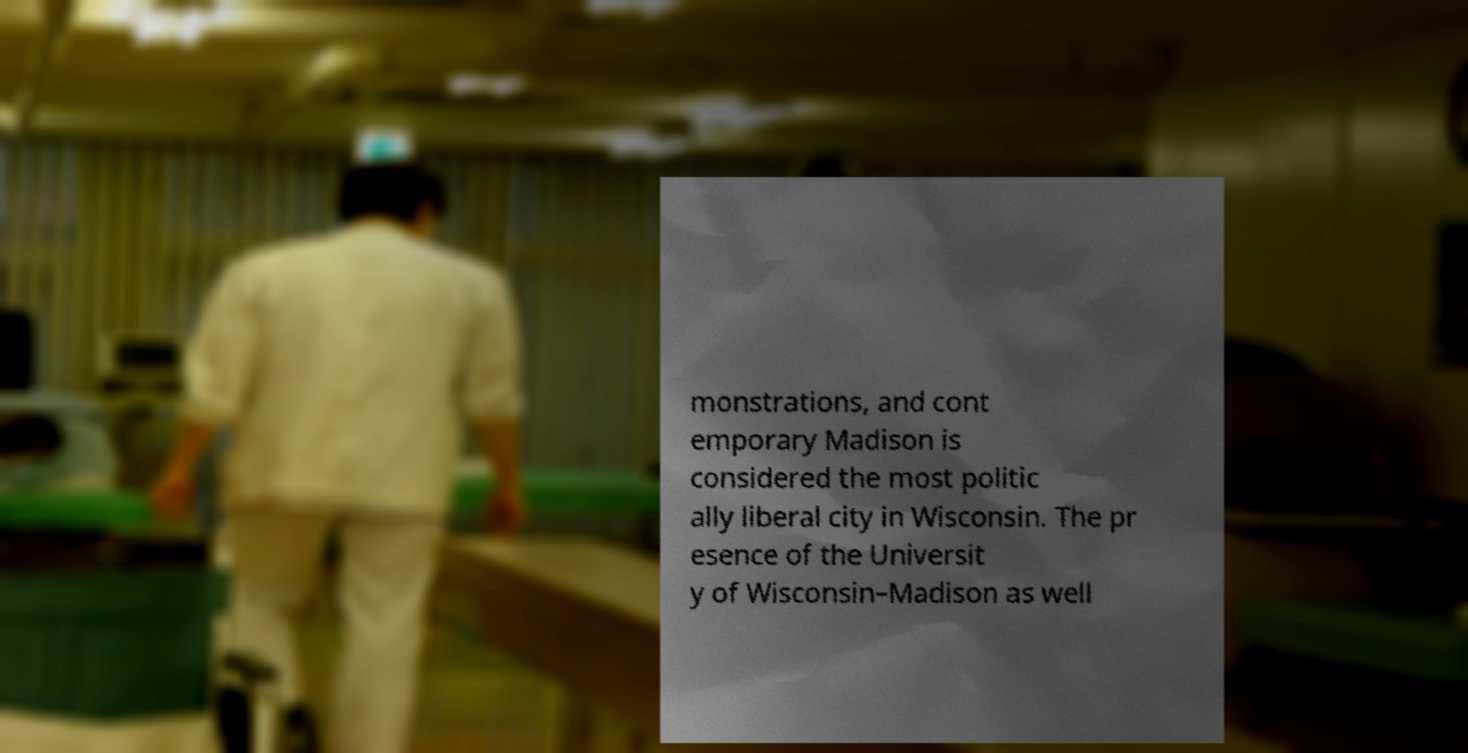Could you assist in decoding the text presented in this image and type it out clearly? monstrations, and cont emporary Madison is considered the most politic ally liberal city in Wisconsin. The pr esence of the Universit y of Wisconsin–Madison as well 